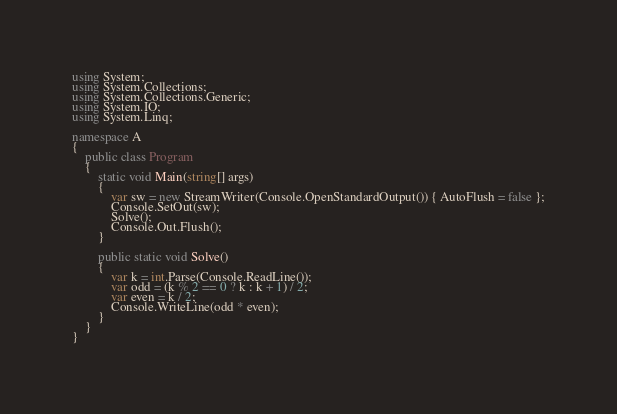<code> <loc_0><loc_0><loc_500><loc_500><_C#_>using System;
using System.Collections;
using System.Collections.Generic;
using System.IO;
using System.Linq;

namespace A
{
    public class Program
    {
        static void Main(string[] args)
        {
            var sw = new StreamWriter(Console.OpenStandardOutput()) { AutoFlush = false };
            Console.SetOut(sw);
            Solve();
            Console.Out.Flush();
        }

        public static void Solve()
        {
            var k = int.Parse(Console.ReadLine());
            var odd = (k % 2 == 0 ? k : k + 1) / 2;
            var even = k / 2;
            Console.WriteLine(odd * even);
        }
    }
}
</code> 